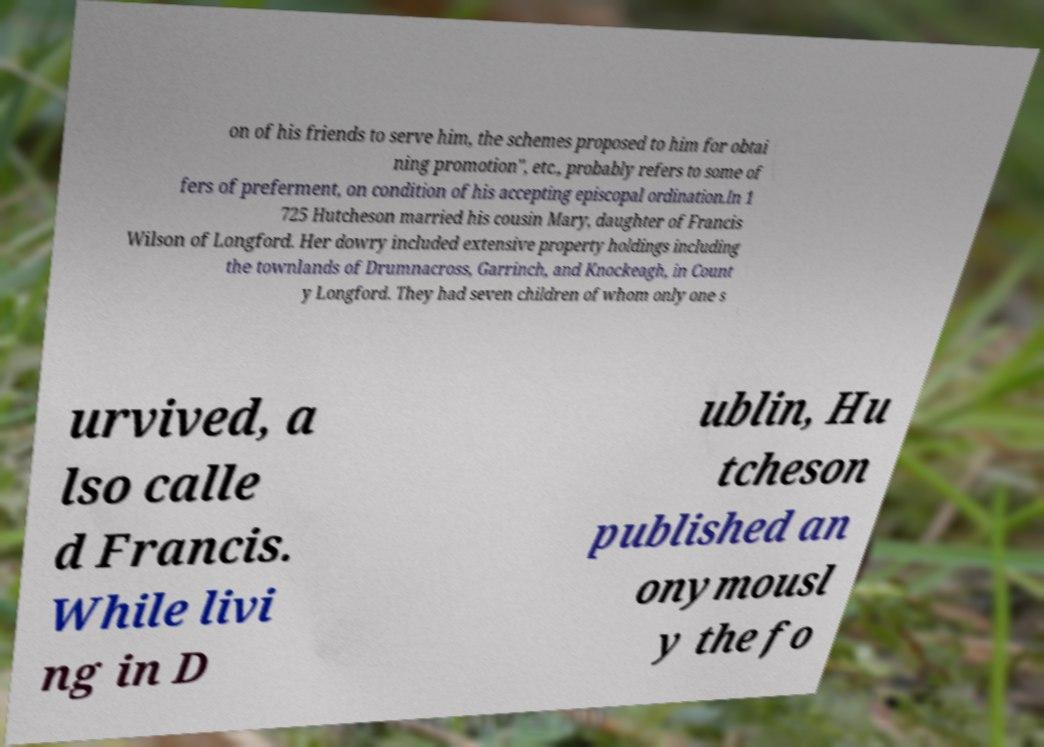For documentation purposes, I need the text within this image transcribed. Could you provide that? on of his friends to serve him, the schemes proposed to him for obtai ning promotion", etc., probably refers to some of fers of preferment, on condition of his accepting episcopal ordination.In 1 725 Hutcheson married his cousin Mary, daughter of Francis Wilson of Longford. Her dowry included extensive property holdings including the townlands of Drumnacross, Garrinch, and Knockeagh, in Count y Longford. They had seven children of whom only one s urvived, a lso calle d Francis. While livi ng in D ublin, Hu tcheson published an onymousl y the fo 